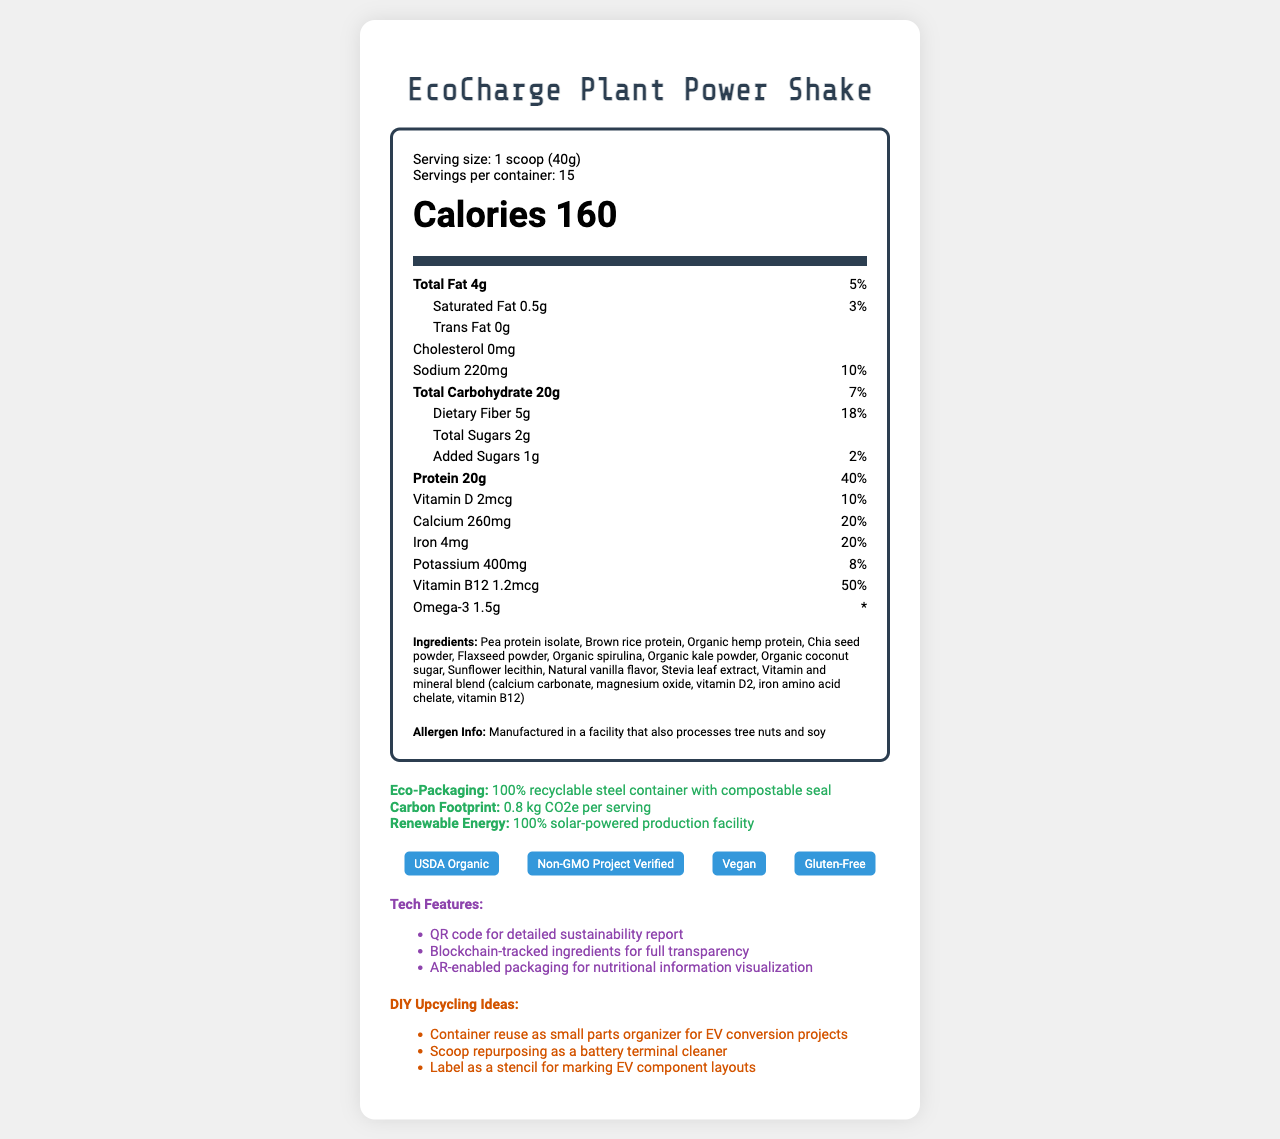how many calories are in one serving of the EcoCharge Plant Power Shake? The document states that each serving contains 160 calories.
Answer: 160 what is the daily value percentage of total fat per serving? The document shows that the total fat amount is 4g, which is 5% of the daily value.
Answer: 5% how much dietary fiber is in each serving, and what percentage of the daily value does this represent? Each serving contains 5g of dietary fiber, which is 18% of the daily value according to the document.
Answer: 5g, 18% how many grams of total carbohydrates are in one scoop of the shake? The document lists the total carbohydrate content as 20g per serving.
Answer: 20g is there any cholesterol in the EcoCharge Plant Power Shake? The document specifies that the cholesterol amount is 0mg.
Answer: No what is the serving size for the EcoCharge Plant Power Shake? The document lists the serving size as 1 scoop (40g).
Answer: 1 scoop (40g) how much protein is in each serving? According to the document, each serving contains 20g of protein.
Answer: 20g which vitamin or mineral has the highest daily value percentage per serving in this shake? A. Vitamin D B. Calcium C. Iron D. Vitamin B12 The document shows that Vitamin B12 has a daily value percentage of 50%, which is higher than the others listed.
Answer: D. Vitamin B12 how many servings are there per container of the EcoCharge Plant Power Shake? A. 10 B. 15 C. 20 D. 25 The document indicates that there are 15 servings per container.
Answer: B. 15 is the packaging for the EcoCharge Plant Power Shake eco-friendly? The document mentions the packaging is 100% recyclable steel with a compostable seal, indicating eco-friendliness.
Answer: Yes how much sodium is there in one serving, and what is the daily value percentage? Each serving contains 220mg of sodium, which is 10% of the daily value.
Answer: 220mg, 10% what certifications does the Sustainable Plant-Based Meal Replacement Shake have? The document lists all these certifications indicating the shake's compliance.
Answer: USDA Organic, Non-GMO Project Verified, Vegan, Gluten-Free is the product suitable for vegans? The document includes the "Vegan" certification, indicating the product is suitable for vegans.
Answer: Yes summarize the main idea of the document. The document provides detailed nutritional information, health benefits, eco-friendly points, certifications, and innovative features of the EcoCharge Plant Power Shake.
Answer: The EcoCharge Plant Power Shake is a sustainable, plant-based meal replacement shake designed for eco-conscious individuals. Each serving (40g) contains 160 calories, 20g of protein, substantial dietary fiber, and low sugar content. It includes essential vitamins and minerals, is free from cholesterol, and uses eco-friendly packaging. The shake is certified USDA Organic, Non-GMO, Vegan, and Gluten-Free, and incorporates advanced features like blockchain-tracked ingredients and AR-enabled packaging. The document also suggests upcycling ideas for the packaging. what specific tech features are included with the product? The document lists these three tech features associated with the product.
Answer: QR code for detailed sustainability report, Blockchain-tracked ingredients for full transparency, AR-enabled packaging for nutritional information visualization can you determine the manufacturing location of the product? The document doesn't provide any information about the manufacturing location of the product.
Answer: Not enough information 